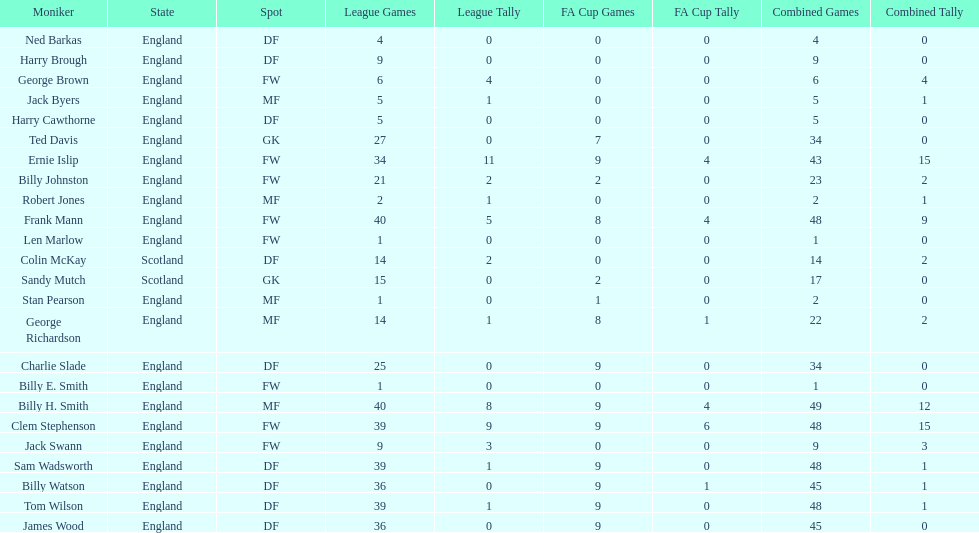What is the last name listed on this chart? James Wood. 